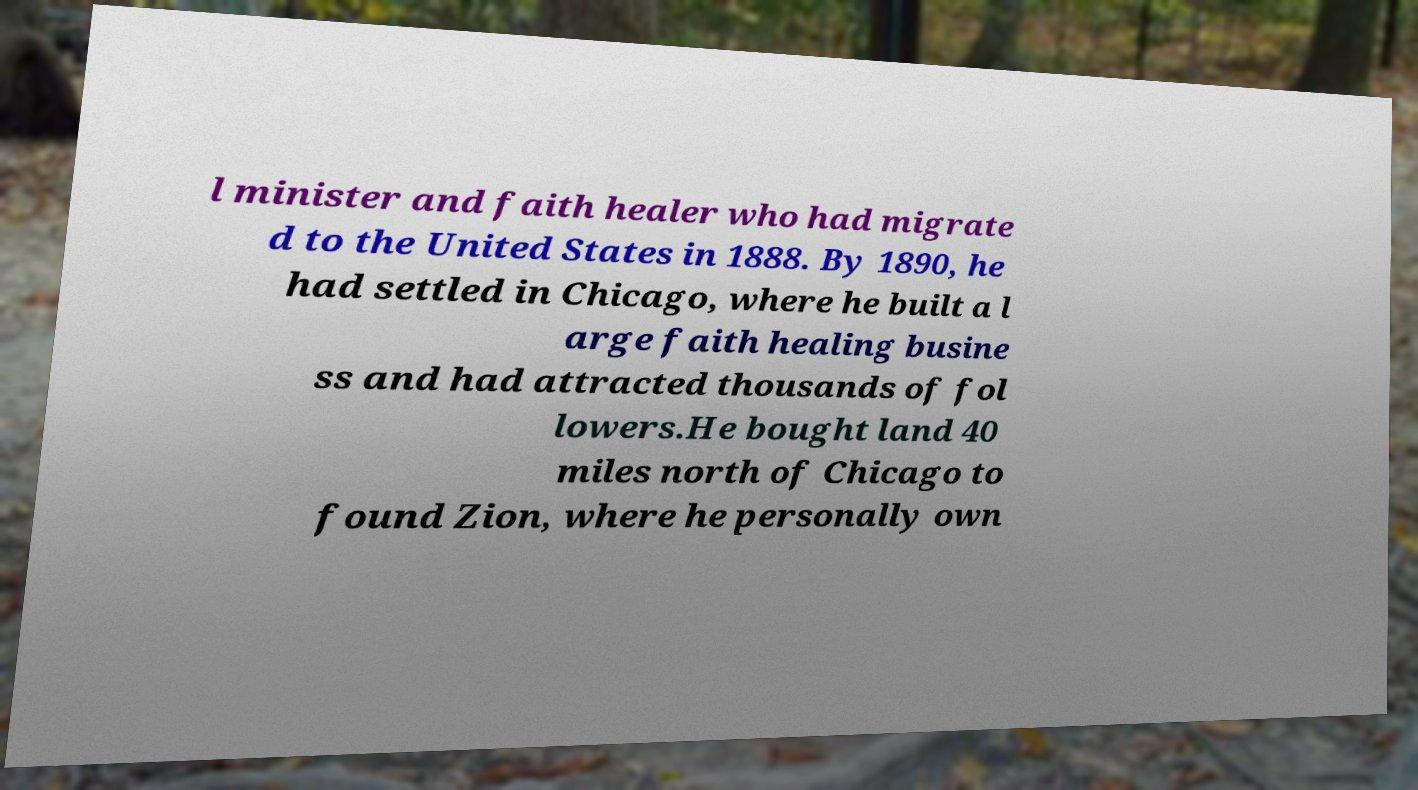What messages or text are displayed in this image? I need them in a readable, typed format. l minister and faith healer who had migrate d to the United States in 1888. By 1890, he had settled in Chicago, where he built a l arge faith healing busine ss and had attracted thousands of fol lowers.He bought land 40 miles north of Chicago to found Zion, where he personally own 